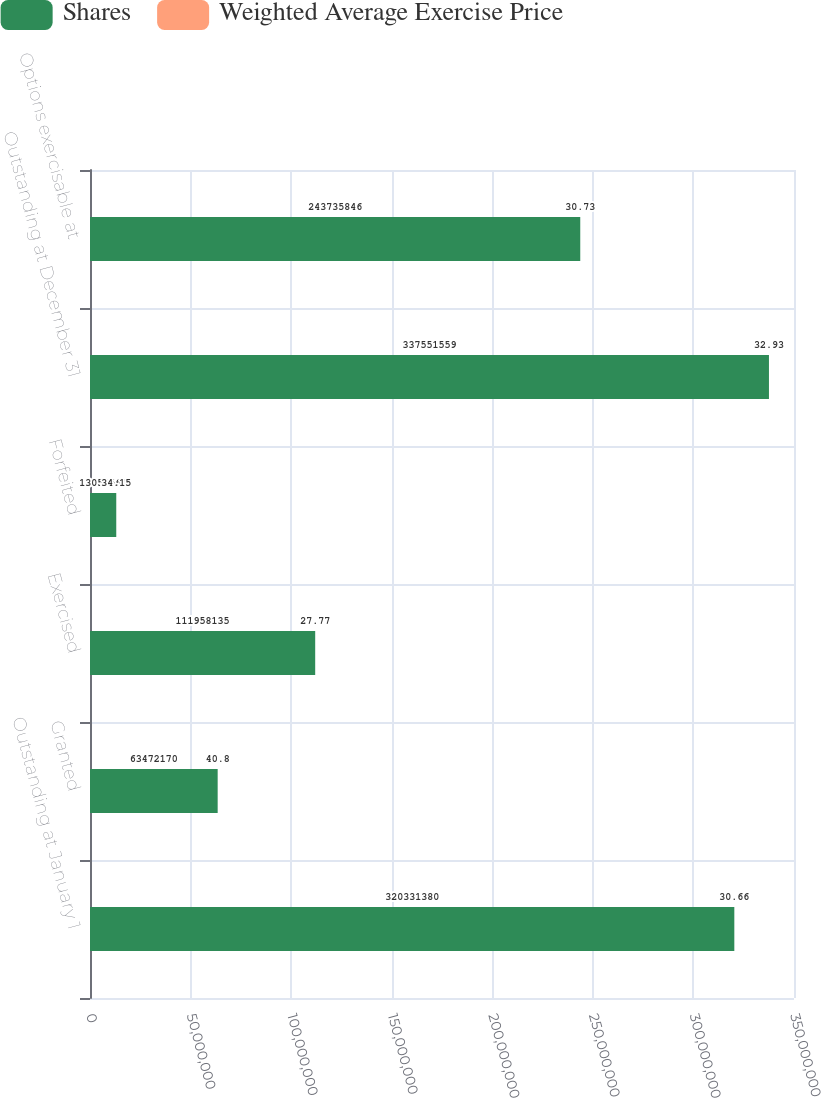Convert chart to OTSL. <chart><loc_0><loc_0><loc_500><loc_500><stacked_bar_chart><ecel><fcel>Outstanding at January 1<fcel>Granted<fcel>Exercised<fcel>Forfeited<fcel>Outstanding at December 31<fcel>Options exercisable at<nl><fcel>Shares<fcel>3.20331e+08<fcel>6.34722e+07<fcel>1.11958e+08<fcel>1.30556e+07<fcel>3.37552e+08<fcel>2.43736e+08<nl><fcel>Weighted Average Exercise Price<fcel>30.66<fcel>40.8<fcel>27.77<fcel>34.15<fcel>32.93<fcel>30.73<nl></chart> 